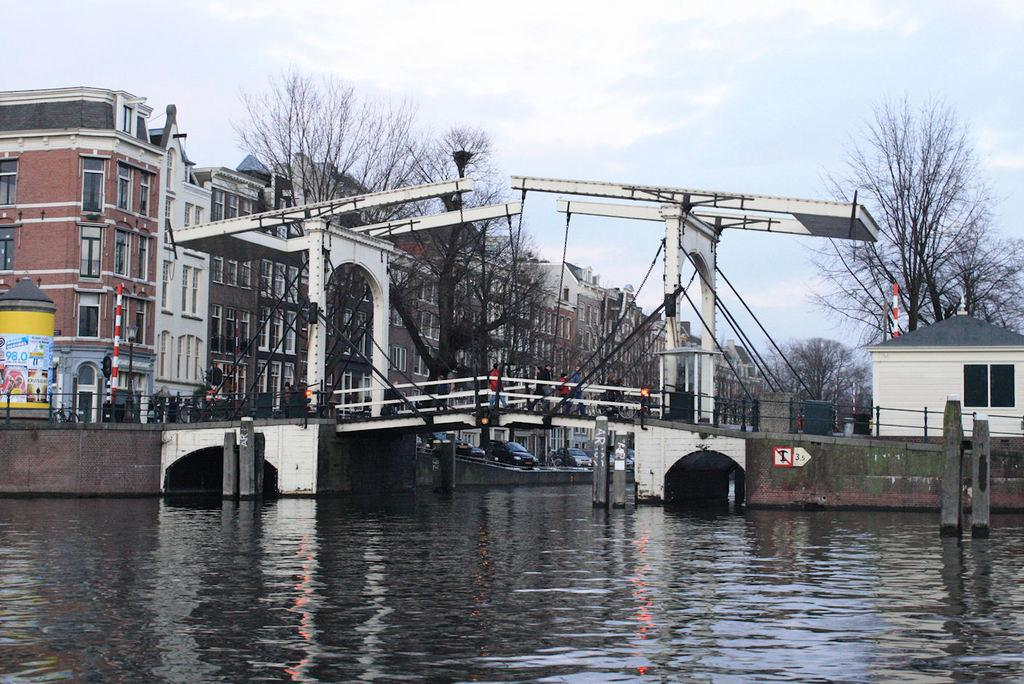What body of water is present in the image? There is a river in the image. What is built above the river? There is a bridge above the river. What are people doing on the bridge? People are walking on the bridge. What can be seen in the distance in the image? There are buildings and trees in the background of the image. Where is the pin located in the image? There is no pin present in the image. What does the father do in the image? There is no father present in the image. 